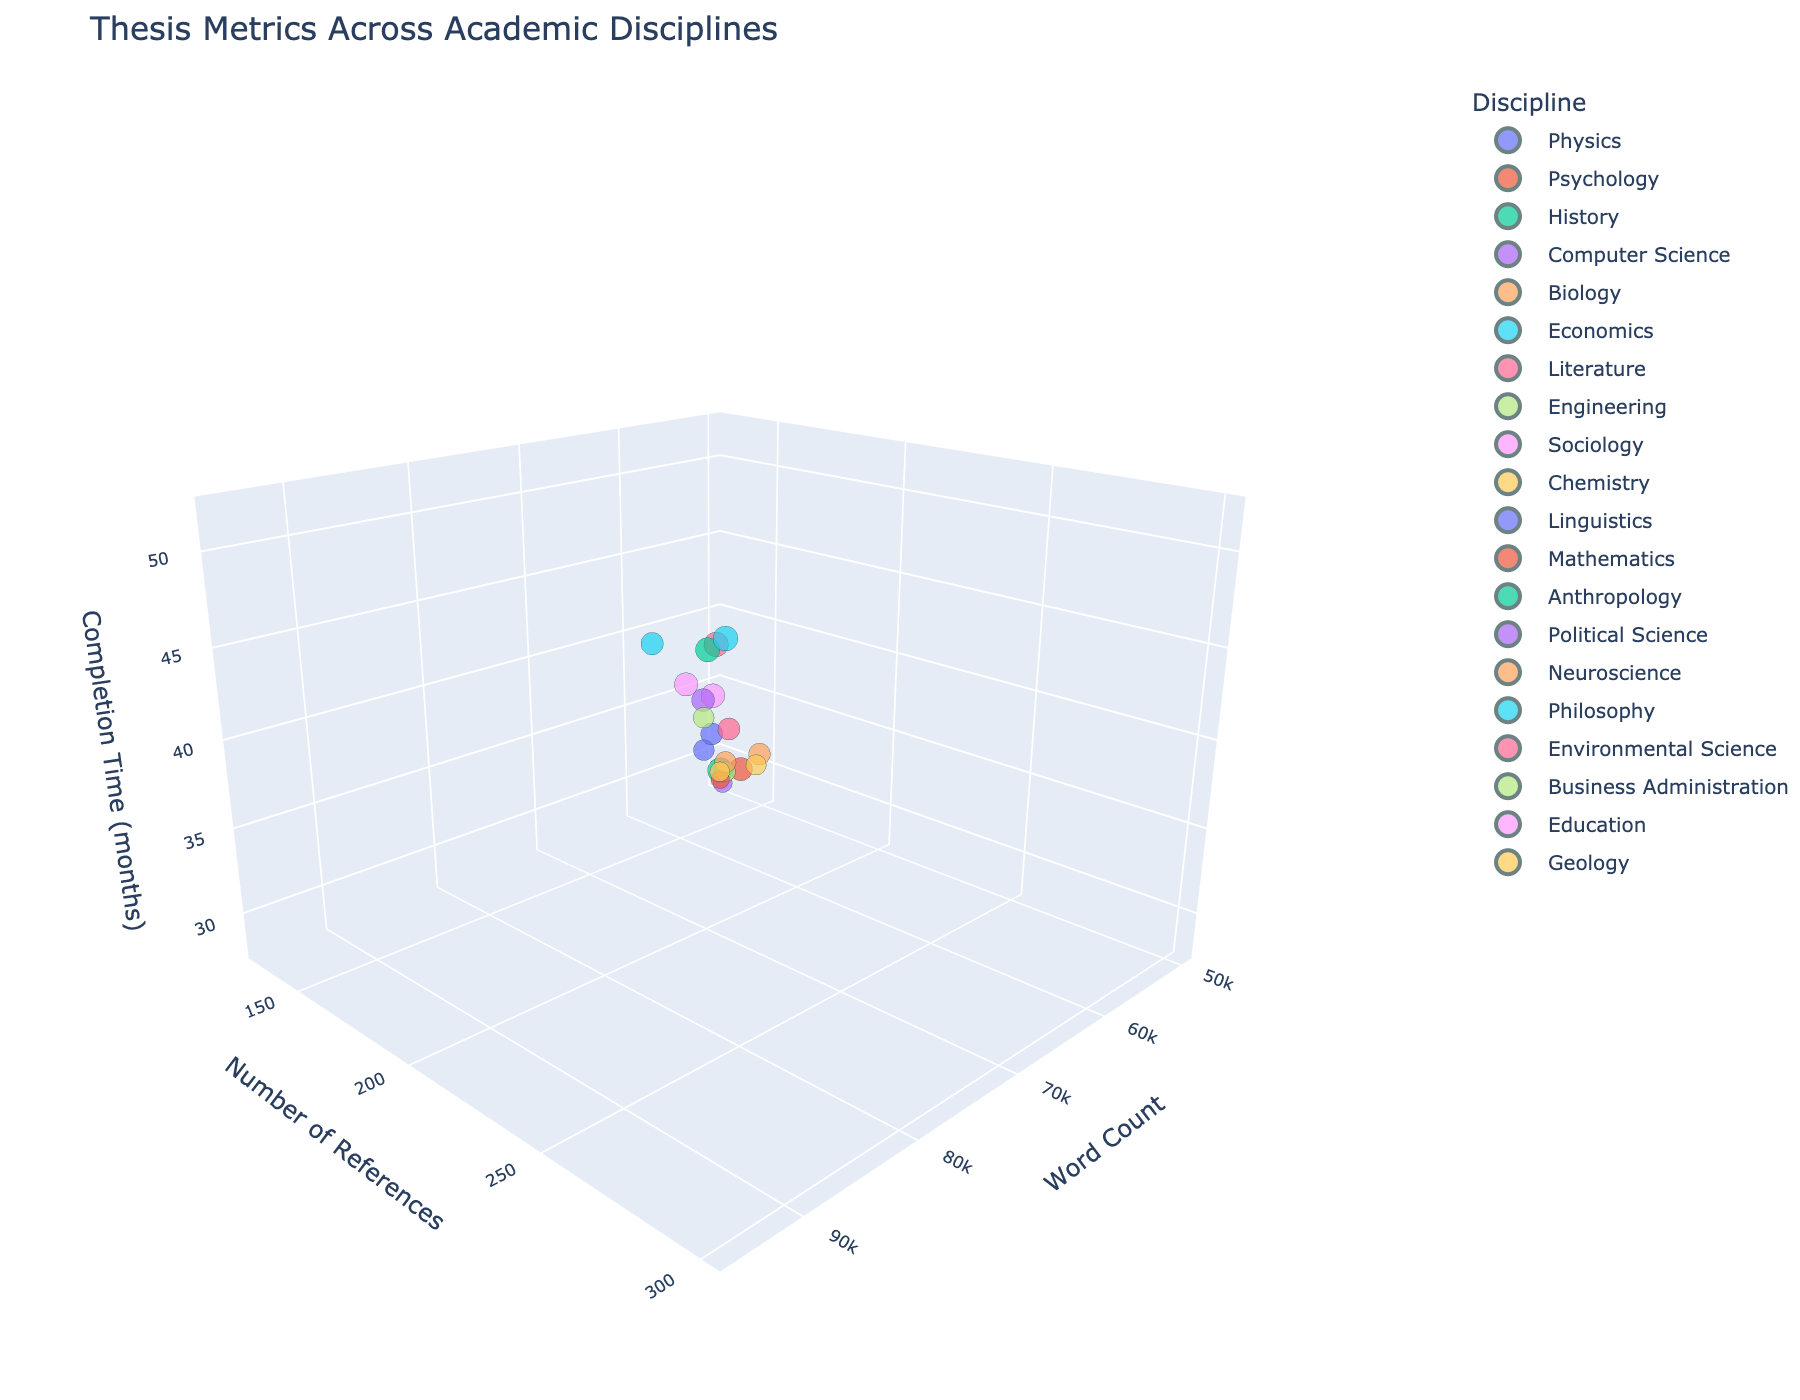What is the title of the figure? The title of the figure is usually displayed at the top, which provides an overview of what the plot is about. By looking at the top section of the figure, we can see the title "Thesis Metrics Across Academic Disciplines"
Answer: Thesis Metrics Across Academic Disciplines How many academic disciplines are represented in the plot? Each data point is color-coded and labeled by the discipline name. By counting the different colors or labels in the legend, we can determine that there are 20 academic disciplines represented
Answer: 20 Which academic discipline has the shortest completion time for the thesis? To find this, examine the z-axis which represents the completion time. The discipline with the data point positioned lowest on this axis (closest to 28 months) represents the shortest completion time. By looking at the plot, we find that Mathematics has the shortest completion time at 28 months
Answer: Mathematics Which academic discipline has the highest word count? The word count is represented on the x-axis. The discipline with the data point furthest to the right on this axis corresponds to the highest word count. We see that Philosophy has the highest word count at 92,000
Answer: Philosophy What is the number of references cited in the Biology thesis? To identify this, find the marker for Biology, and read its y-axis value. The Biology discipline's data point is located where the y-axis (number of references) is 220
Answer: 220 What is the average completion time for all the disciplines? The completion time for each discipline is given on the z-axis. Summing up all completion times: 36 + 42 + 48 + 30 + 39 + 45 + 51 + 33 + 47 + 35 + 40 + 28 + 50 + 44 + 37 + 52 + 41 + 38 + 46 + 32, results in a total of 744. Dividing by 20 disciplines gives an average of 744 ÷ 20 = 37.2
Answer: 37.2 months Which discipline has both a high word count and a high number of references? To find this, look for data points that are both rightmost on the x-axis (high word count) and uppermost on the y-axis (high number of references). The data point for History is in the upper-right section of the plot, indicating both a high word count (95,000) and a high number of references (300)
Answer: History What is the range of word count values in the dataset? The range is obtained by subtracting the smallest word count from the largest. The smallest word count in the plot is 50,000 (Mathematics) and the largest is 95,000 (History), hence, 95,000 - 50,000 = 45,000
Answer: 45,000 Which disciplines have a completion time exceeding 45 months? To find this, check the z-axis for data points placed above 45 months. The disciplines fulfilling this criterion are Literature (51), Anthropology (50), Philosophy (52), and Education (46)
Answer: Literature, Anthropology, Philosophy, Education Is there a visible correlation between word count and completion time? By observing the plot, we notice that data points tend to rise higher on the z-axis as they spread further on the x-axis indicating that longer-worded theses correlate with longer completion times. This visual trend suggests a positive correlation
Answer: Yes, positive correlation 